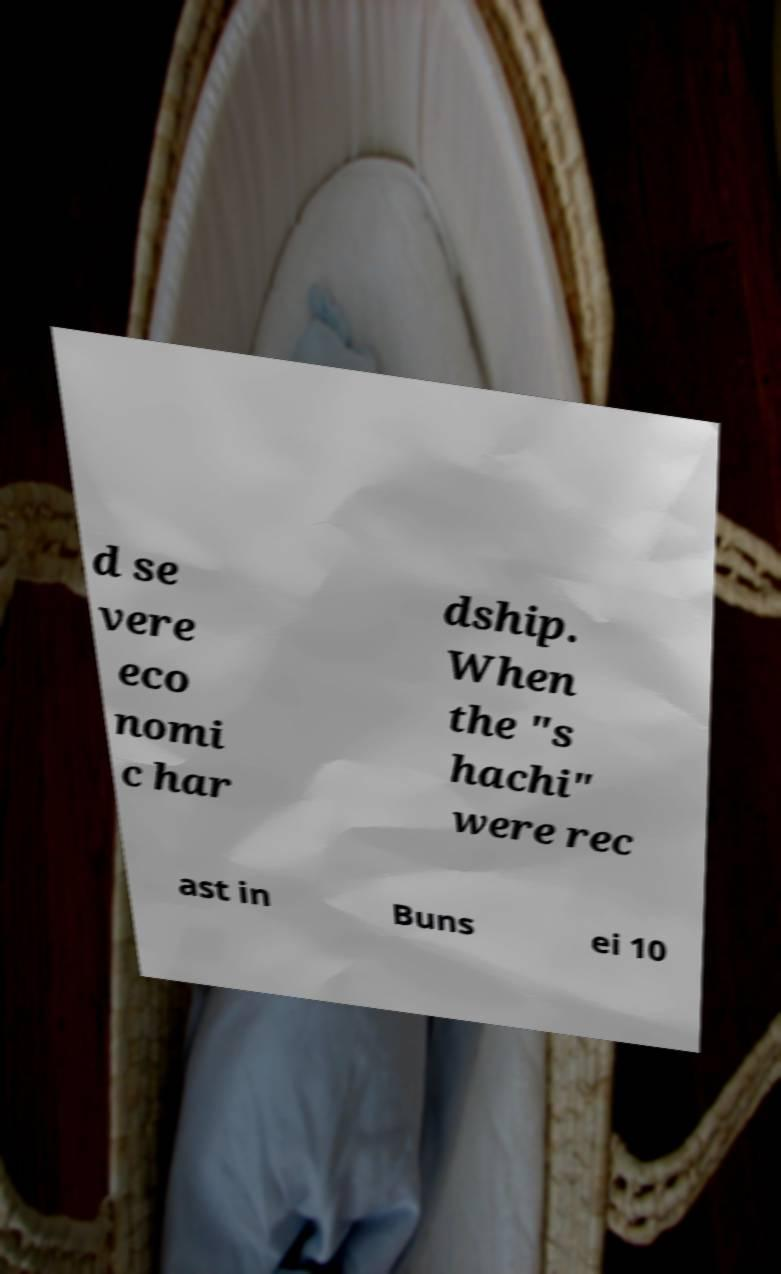Can you read and provide the text displayed in the image?This photo seems to have some interesting text. Can you extract and type it out for me? d se vere eco nomi c har dship. When the "s hachi" were rec ast in Buns ei 10 